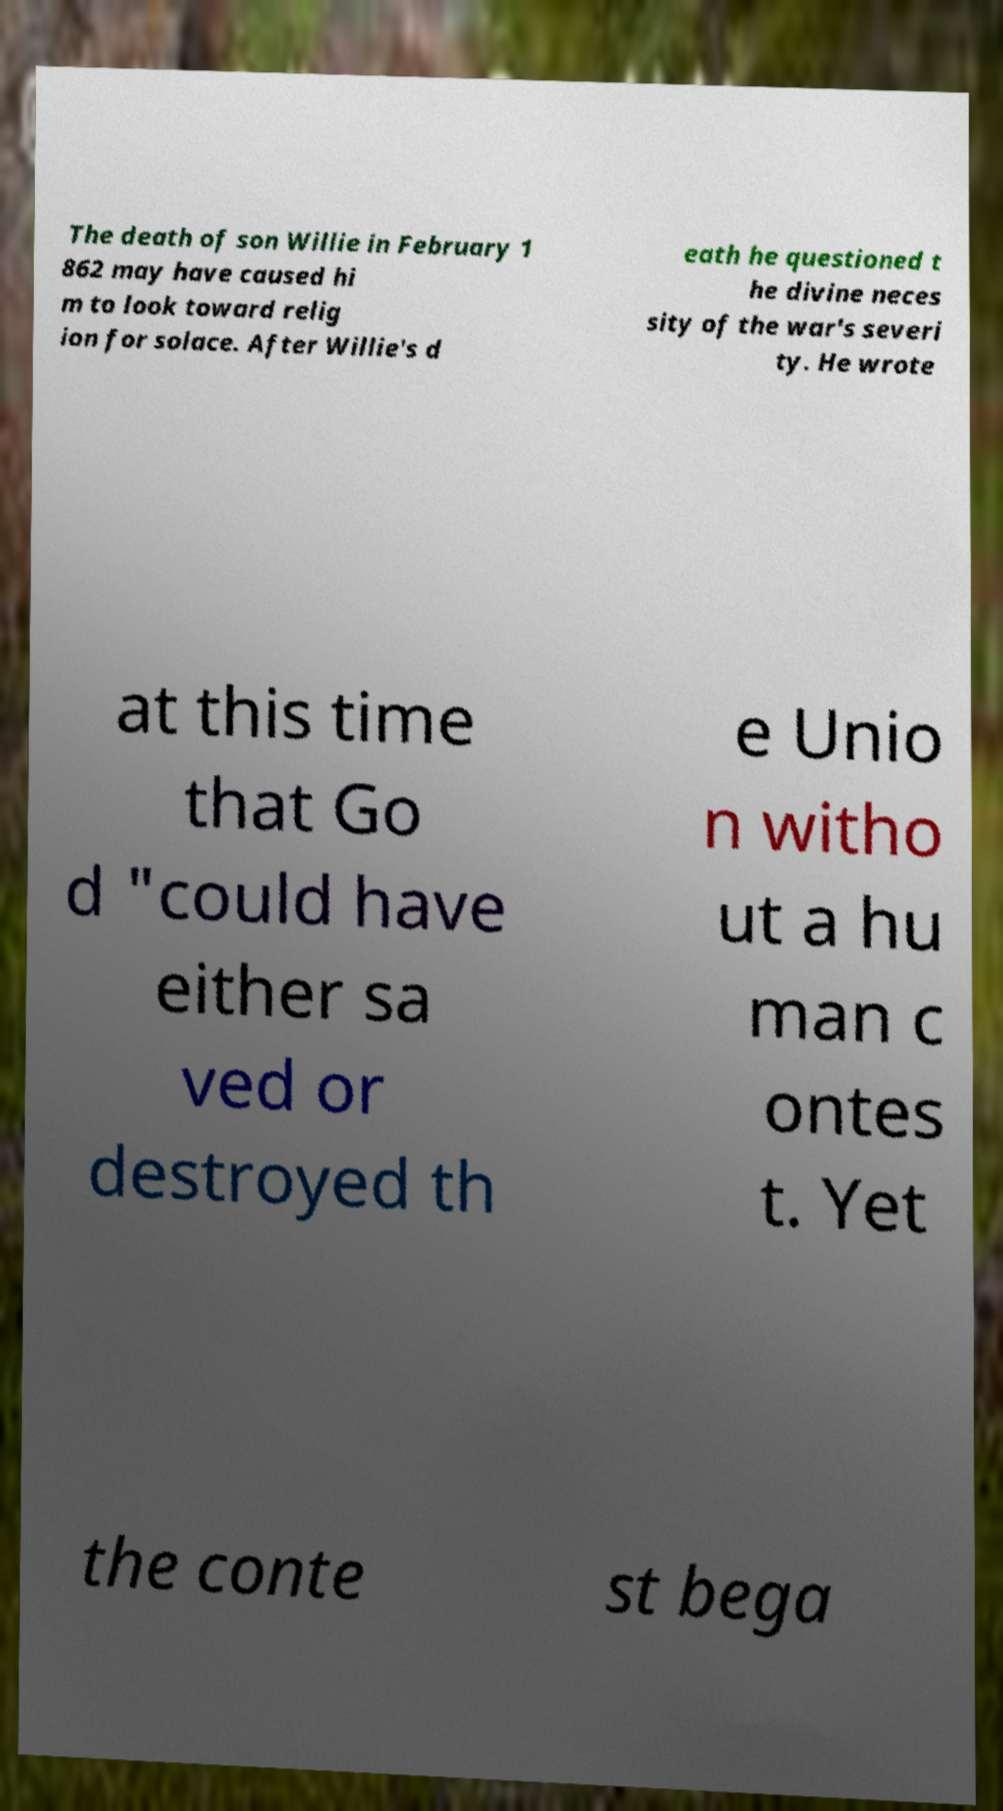What messages or text are displayed in this image? I need them in a readable, typed format. The death of son Willie in February 1 862 may have caused hi m to look toward relig ion for solace. After Willie's d eath he questioned t he divine neces sity of the war's severi ty. He wrote at this time that Go d "could have either sa ved or destroyed th e Unio n witho ut a hu man c ontes t. Yet the conte st bega 